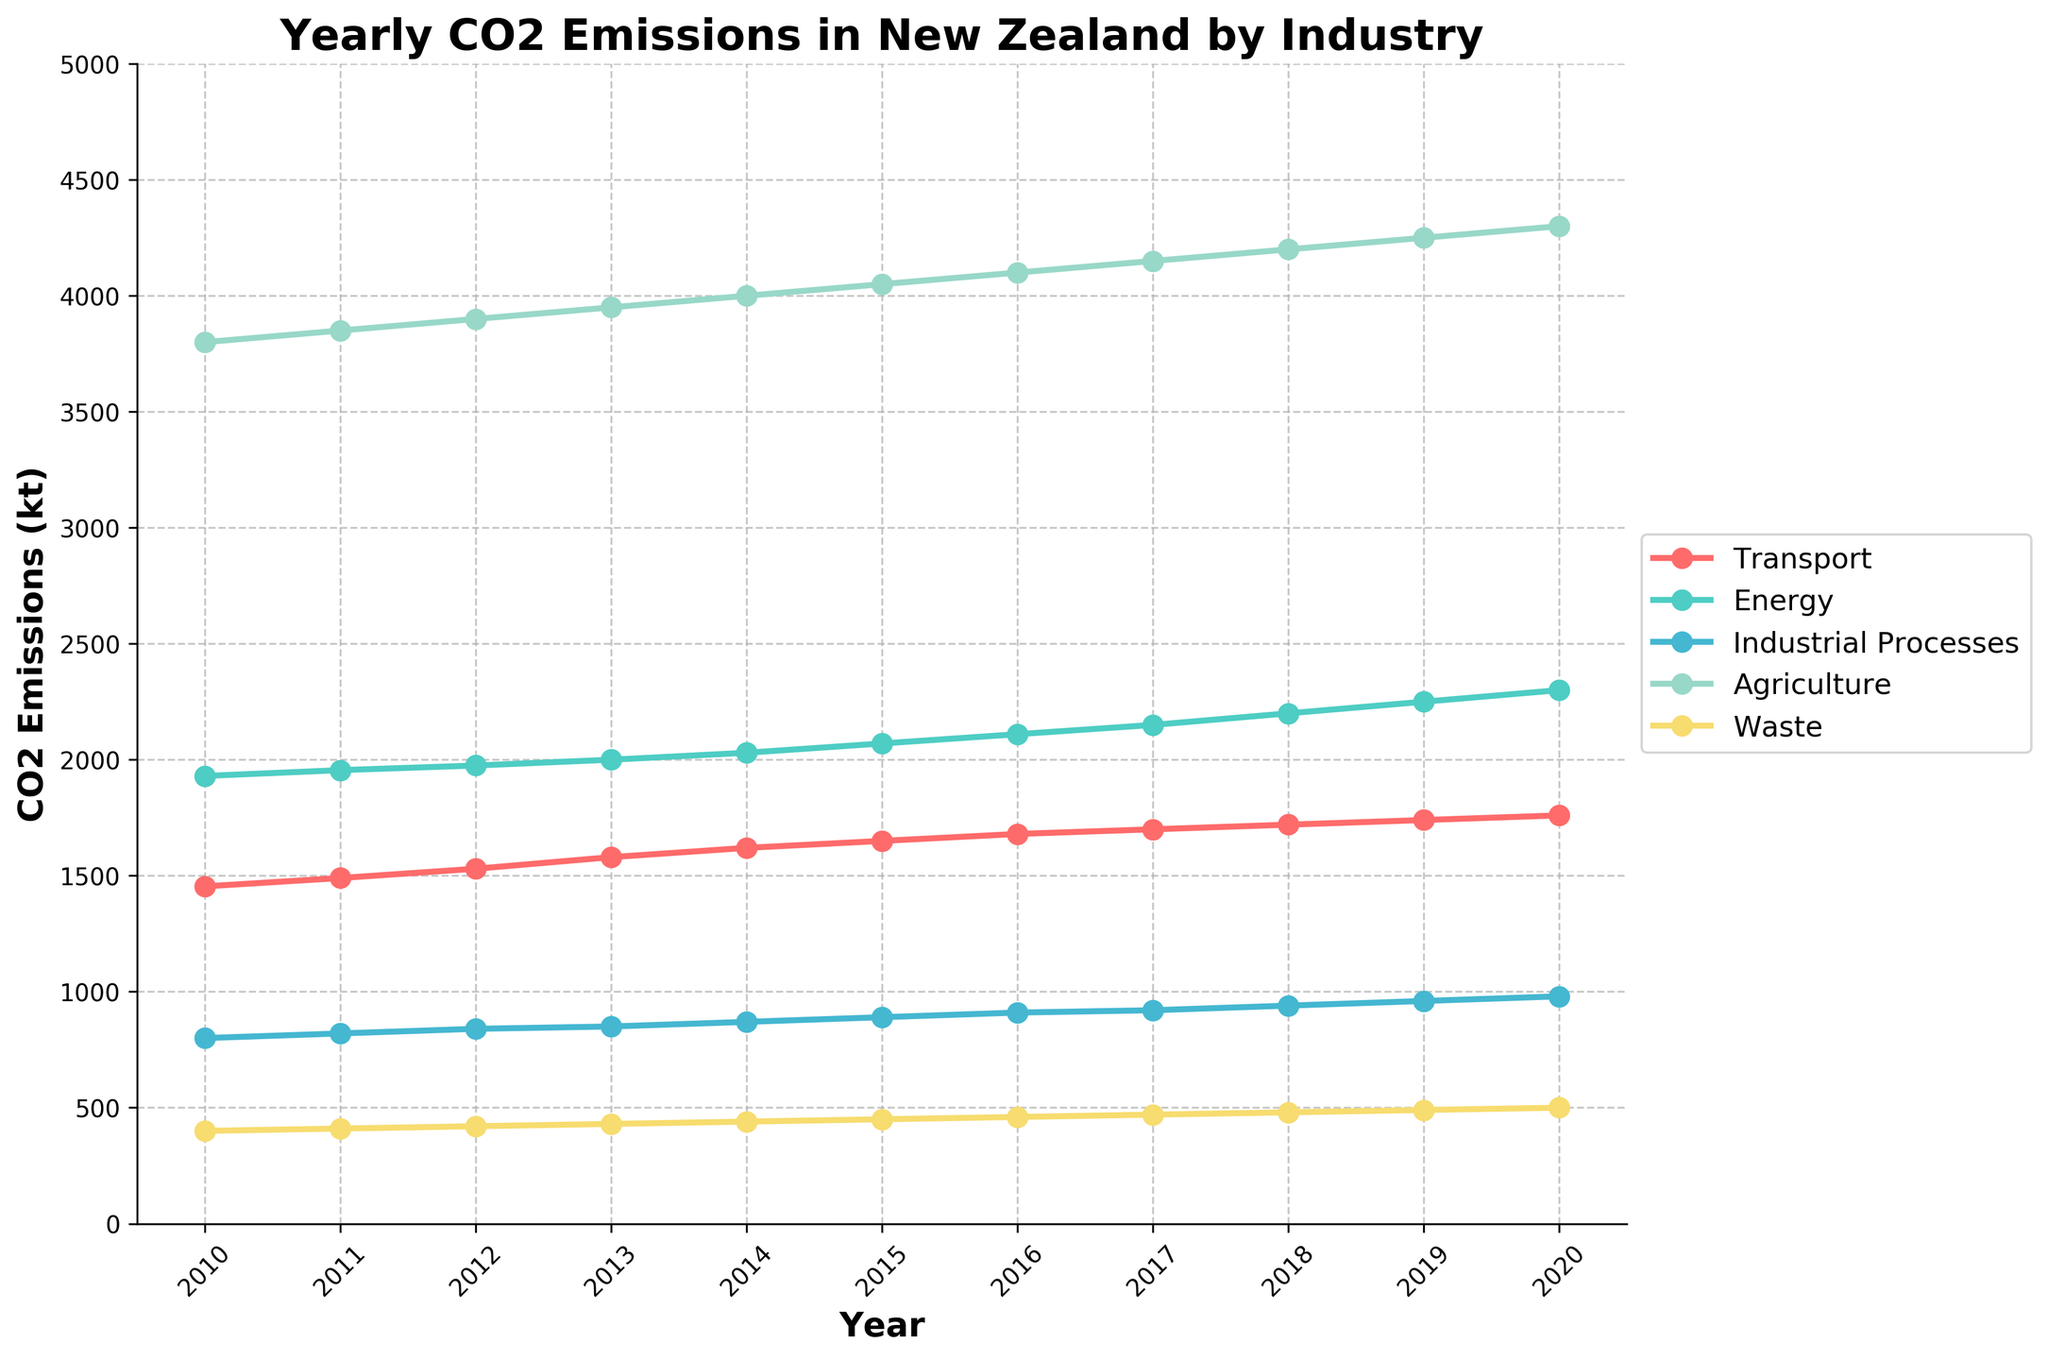What is the title of the plot? The title of the plot is clearly located at the top and it reads 'Yearly CO2 Emissions in New Zealand by Industry'.
Answer: Yearly CO2 Emissions in New Zealand by Industry How many industries’ CO2 emissions are tracked in the plot? The legend on the right-hand side of the plot lists the industries, and you can count them to find the number. There are five industries listed.
Answer: Five Which industry has the highest CO2 emissions in 2020? Look at the end of the lines in 2020 and see which line is at the highest value. Agriculture has the highest CO2 emissions in 2020.
Answer: Agriculture What changes occurred in the CO2 emissions from the Transport industry between 2010 and 2020? Identify the starting and ending points of the Transport line on the Y-axis in 2010 and 2020, respectively, and compare the values. The CO2 emissions from Transport increased from 1454 kt in 2010 to 1760 kt in 2020.
Answer: An increase from 1454 kt to 1760 kt In which year did Transport's CO2 emissions first cross the 1600 kt mark? Follow the line for the Transport industry and identify the year where it first crosses the 1600 kt level on the Y-axis. The line for Transport crosses 1600 kt in 2014.
Answer: 2014 Which two industries show the smallest difference in CO2 emissions in 2020? Look at the values for each industry in 2020 and calculate their differences. The Waste and Industrial Processes have the smallest difference: 500 kt for Waste and 980 kt for Industrial Processes, resulting in a difference of 480 kt.
Answer: Waste and Industrial Processes What is the average CO2 emission for the Energy industry over the given years? Sum the CO2 emissions for the Energy industry from 2010 to 2020 and divide by the number of years to find the average. (1930 + 1955 + 1975 + 2000 + 2030 + 2070 + 2110 + 2150 + 2200 + 2250 + 2300) / 11 = 2061 kt.
Answer: 2061 kt By how much did Agriculture’s CO2 emissions increase from 2010 to 2020? Subtract the CO2 emissions in 2010 from those in 2020 for Agriculture. 4300 kt (2020) - 3800 kt (2010) = 500 kt.
Answer: 500 kt Which industry had the most consistent yearly increase in CO2 emissions? Identify the industry whose line shows the most consistent or linear increase across the years. Energy shows a very steady and linear increase each year.
Answer: Energy 